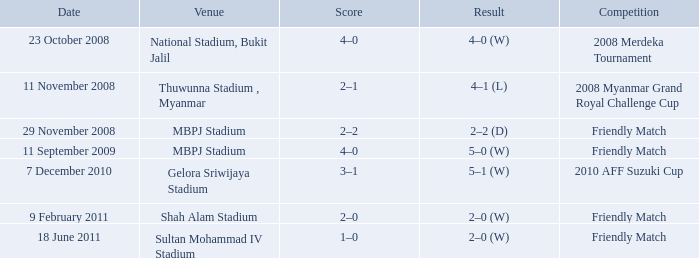At the shah alam stadium, which competition ended with a 2-0 (w) victory? Friendly Match. 